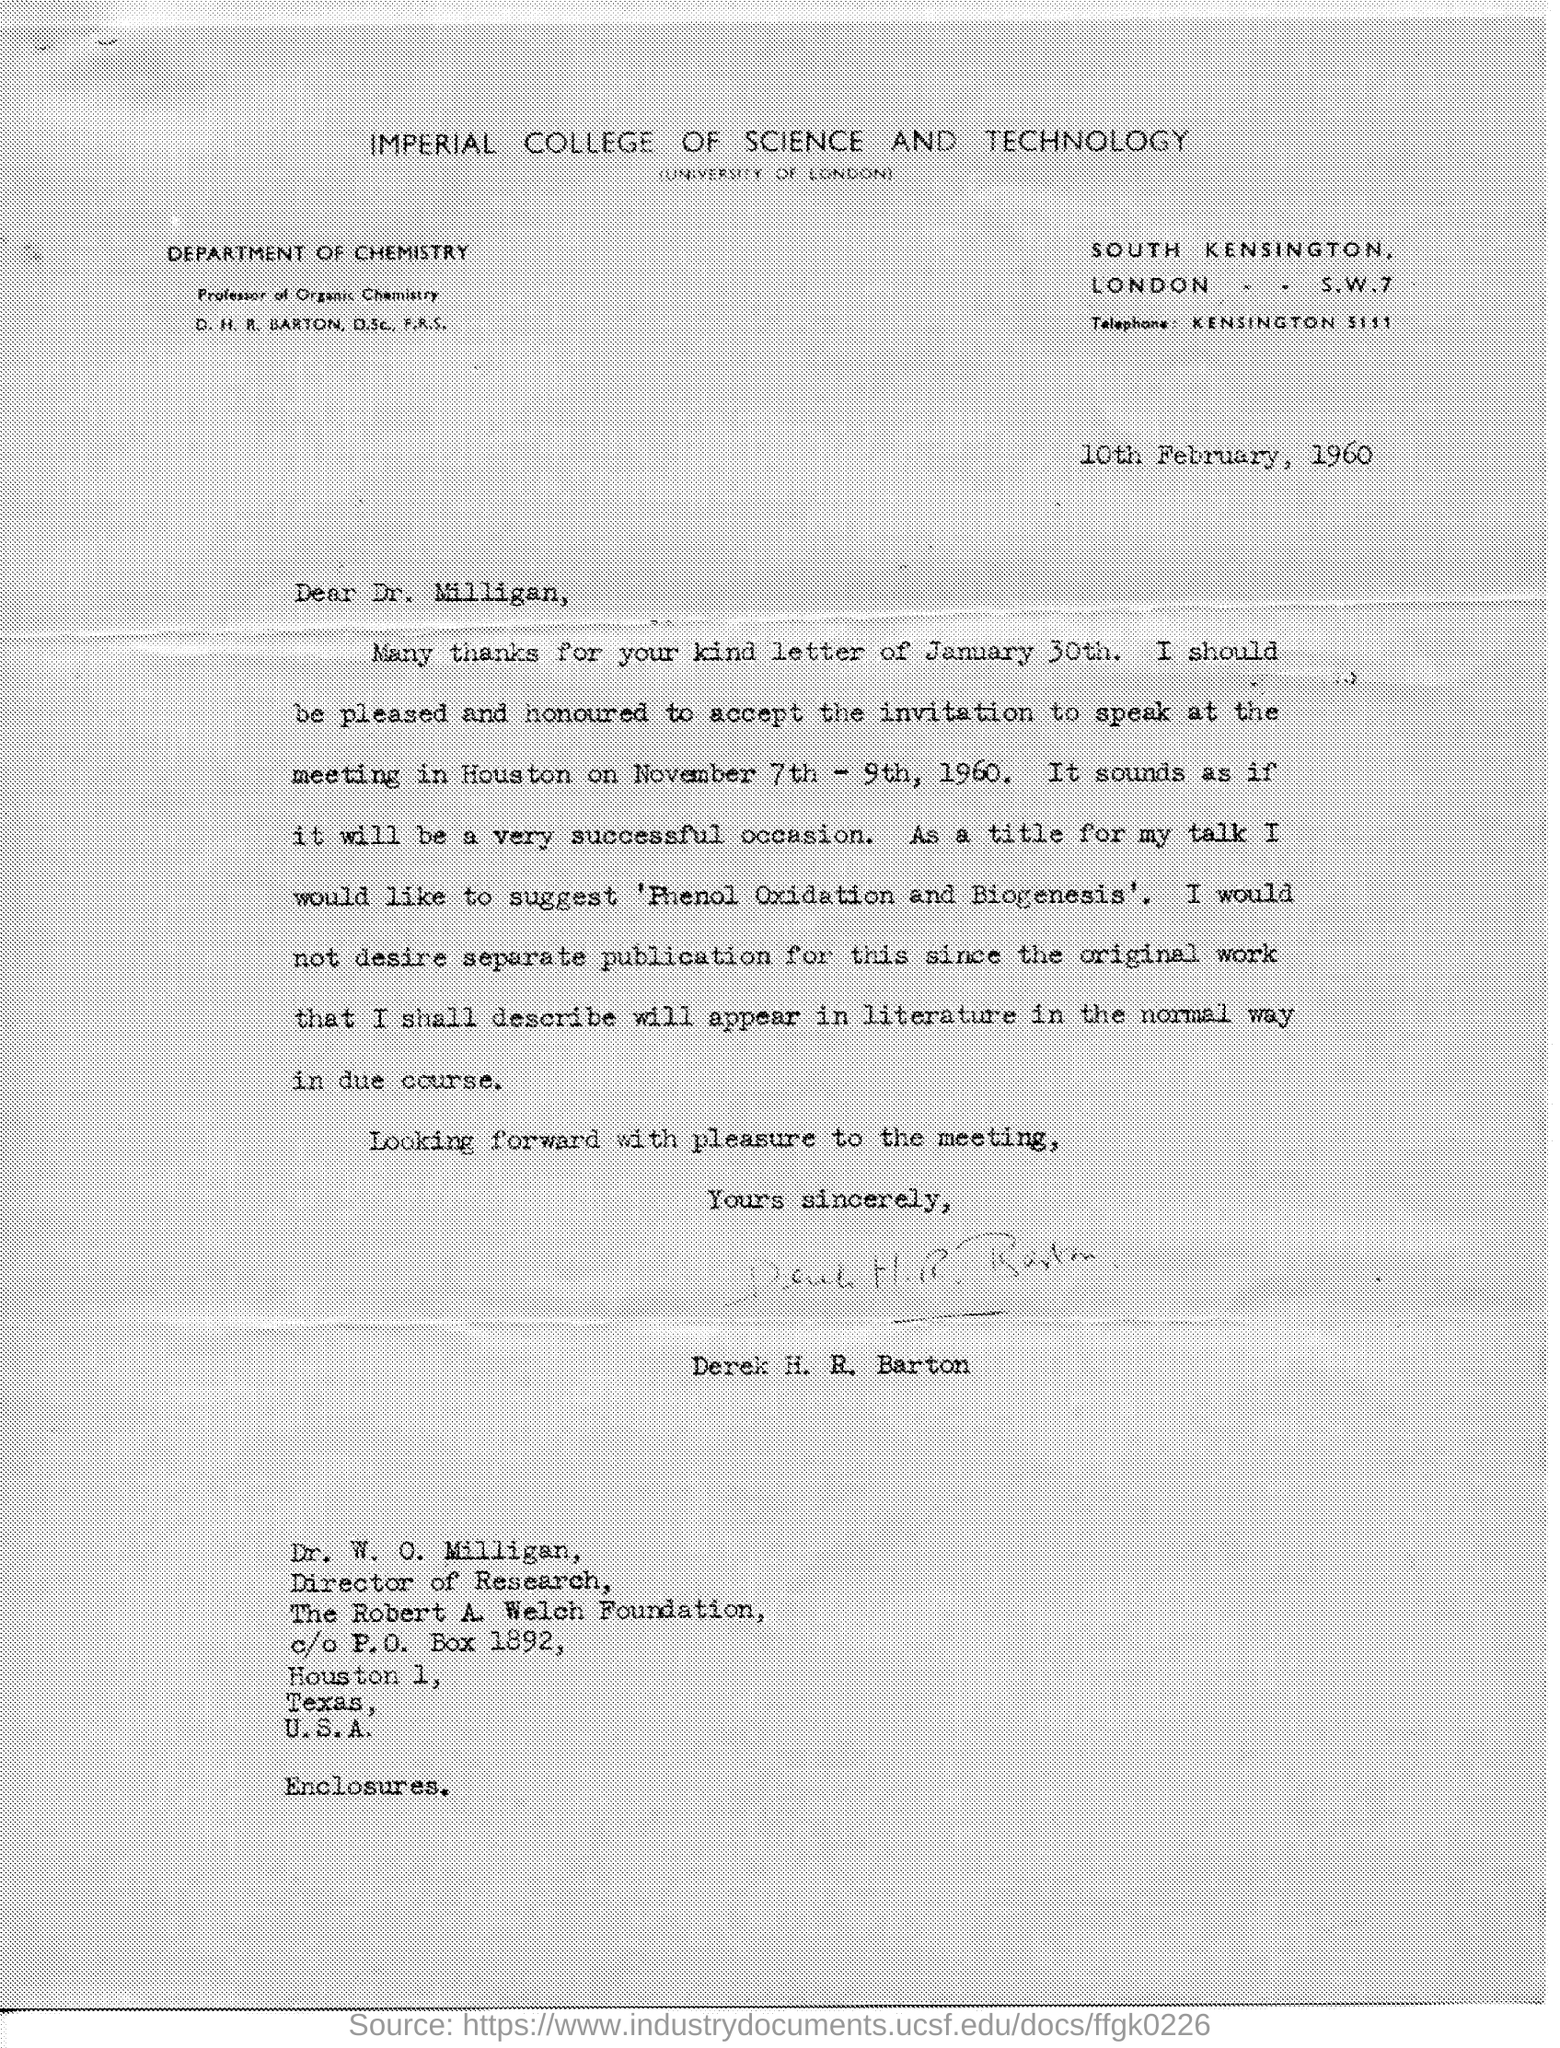Give some essential details in this illustration. The Imperial College of Science and Technology is affiliated with the University of London. The Imperial College of Science and Technology is the name of the college mentioned in the given letter. The name of the department mentioned in the given letter is the Department of Chemistry. Dr. W. O. Milligan's designation is Director. The letter was written to Dr. W. O. Milligan. 